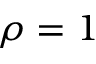<formula> <loc_0><loc_0><loc_500><loc_500>\rho = 1</formula> 